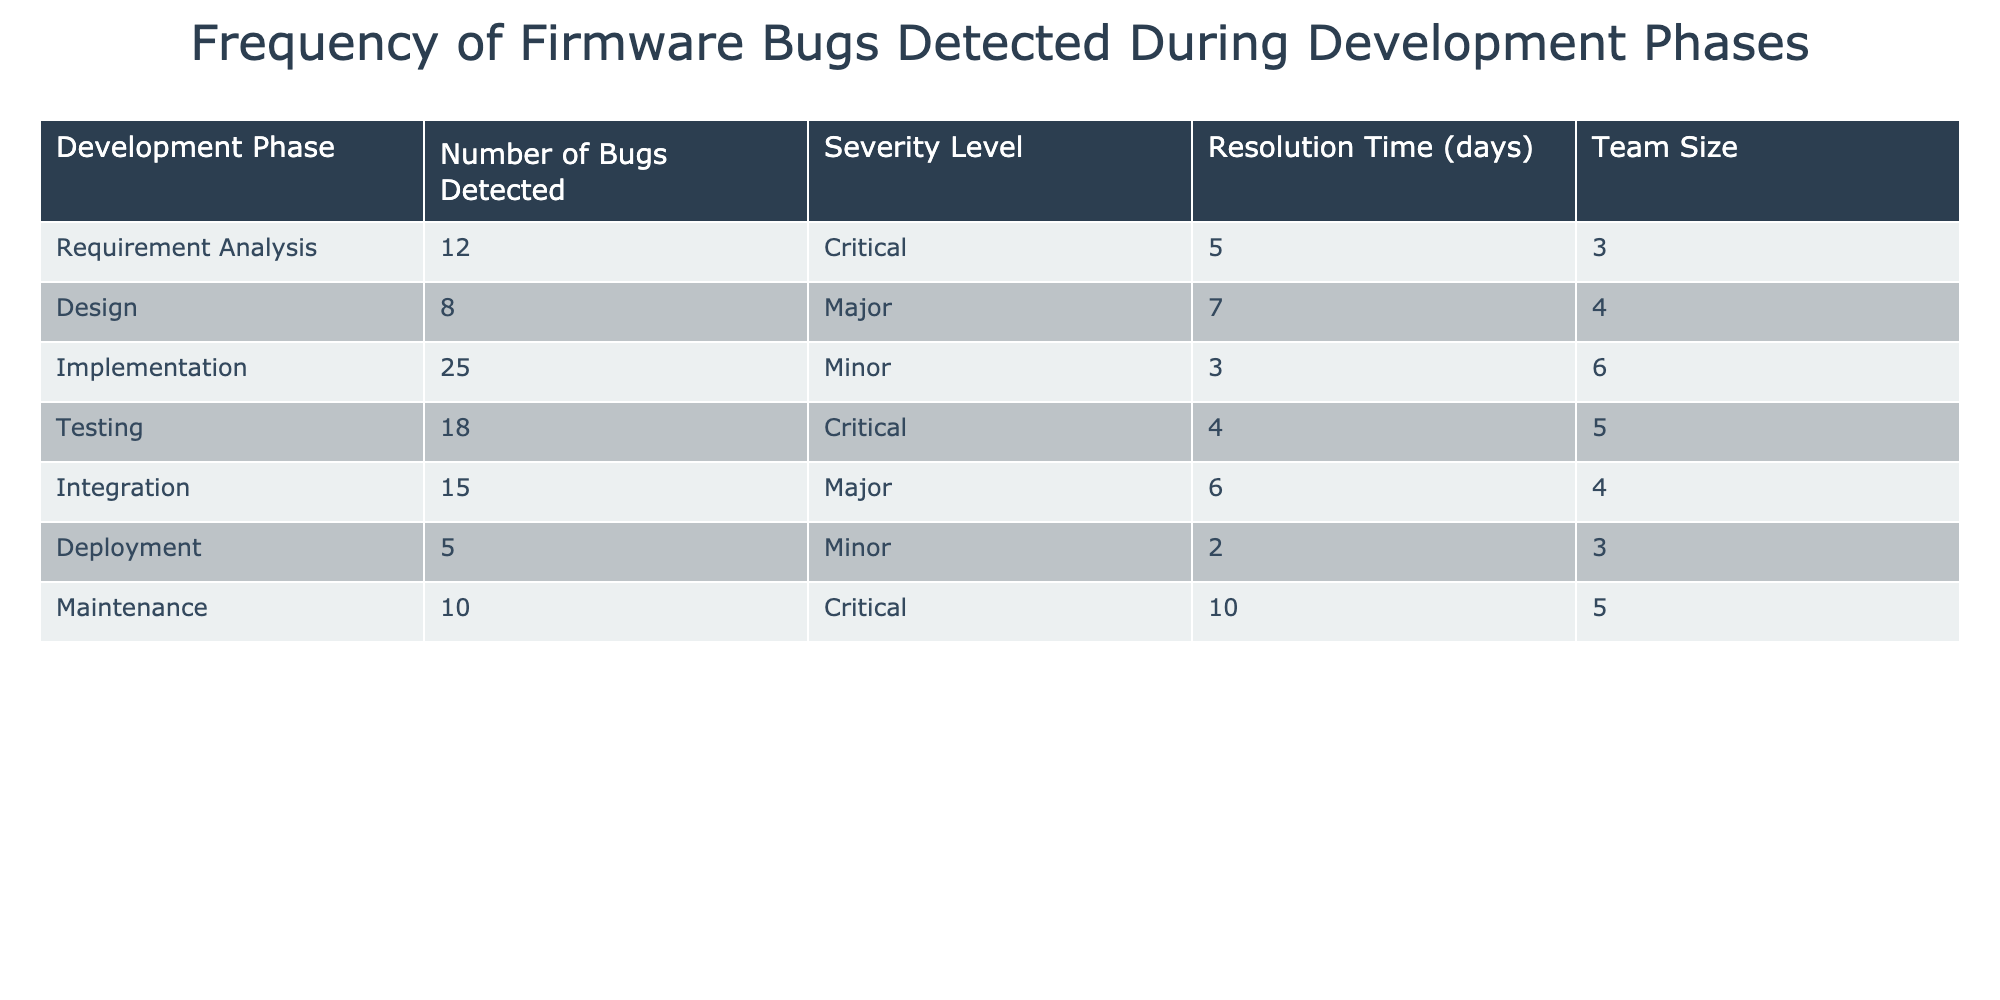What is the number of bugs detected during the Implementation phase? The table lists the number of bugs detected in various development phases. The row for the Implementation phase states that 25 bugs were detected.
Answer: 25 What is the severity level of bugs detected during the Testing phase? In the Testing row of the table, the severity level is specified as Critical.
Answer: Critical What development phase has the highest number of detected bugs? To find this, we need to compare the Number of Bugs Detected across all phases. The Implementation phase has the highest number at 25 bugs.
Answer: Implementation What is the average resolution time for bugs in the Critical severity level? We identify the phases with Critical severity: Requirement Analysis (5 days), Testing (4 days), and Maintenance (10 days). The total resolution time is 5 + 4 + 10 = 19 days, and there are 3 phases; thus, the average is 19/3 = 6.33 days.
Answer: 6.33 days Is the number of bugs detected during the Deployment phase less than 10? The table shows that 5 bugs were detected during Deployment, which is less than 10.
Answer: Yes How many more bugs were detected in the Integration phase compared to the Deployment phase? The Integration phase has 15 bugs while the Deployment phase has 5. Therefore, the difference is 15 - 5 = 10.
Answer: 10 What is the total number of Minor bugs detected across all phases? We look for Minor severity levels in the table. Minor bugs were detected during Implementation (25), Deployment (5). Summing these gives 25 + 5 = 30.
Answer: 30 In which development phase was the shortest resolution time recorded? We need to compare the Resolution Time across all phases. The shortest is 2 days, observed in the Deployment phase.
Answer: Deployment What is the total number of bugs detected in the Requirement Analysis and Design phases combined? Total bugs in Requirement Analysis (12) and Design (8) sums up to 12 + 8 = 20.
Answer: 20 